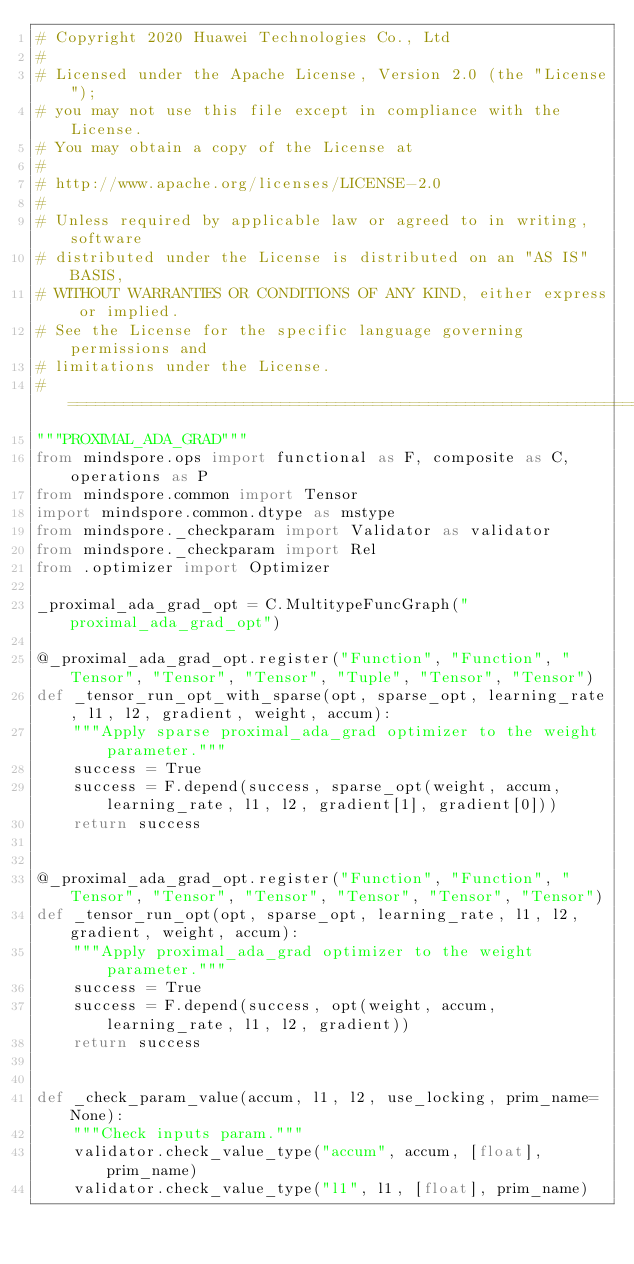Convert code to text. <code><loc_0><loc_0><loc_500><loc_500><_Python_># Copyright 2020 Huawei Technologies Co., Ltd
#
# Licensed under the Apache License, Version 2.0 (the "License");
# you may not use this file except in compliance with the License.
# You may obtain a copy of the License at
#
# http://www.apache.org/licenses/LICENSE-2.0
#
# Unless required by applicable law or agreed to in writing, software
# distributed under the License is distributed on an "AS IS" BASIS,
# WITHOUT WARRANTIES OR CONDITIONS OF ANY KIND, either express or implied.
# See the License for the specific language governing permissions and
# limitations under the License.
# ============================================================================
"""PROXIMAL_ADA_GRAD"""
from mindspore.ops import functional as F, composite as C, operations as P
from mindspore.common import Tensor
import mindspore.common.dtype as mstype
from mindspore._checkparam import Validator as validator
from mindspore._checkparam import Rel
from .optimizer import Optimizer

_proximal_ada_grad_opt = C.MultitypeFuncGraph("proximal_ada_grad_opt")

@_proximal_ada_grad_opt.register("Function", "Function", "Tensor", "Tensor", "Tensor", "Tuple", "Tensor", "Tensor")
def _tensor_run_opt_with_sparse(opt, sparse_opt, learning_rate, l1, l2, gradient, weight, accum):
    """Apply sparse proximal_ada_grad optimizer to the weight parameter."""
    success = True
    success = F.depend(success, sparse_opt(weight, accum, learning_rate, l1, l2, gradient[1], gradient[0]))
    return success


@_proximal_ada_grad_opt.register("Function", "Function", "Tensor", "Tensor", "Tensor", "Tensor", "Tensor", "Tensor")
def _tensor_run_opt(opt, sparse_opt, learning_rate, l1, l2, gradient, weight, accum):
    """Apply proximal_ada_grad optimizer to the weight parameter."""
    success = True
    success = F.depend(success, opt(weight, accum, learning_rate, l1, l2, gradient))
    return success


def _check_param_value(accum, l1, l2, use_locking, prim_name=None):
    """Check inputs param."""
    validator.check_value_type("accum", accum, [float], prim_name)
    validator.check_value_type("l1", l1, [float], prim_name)</code> 